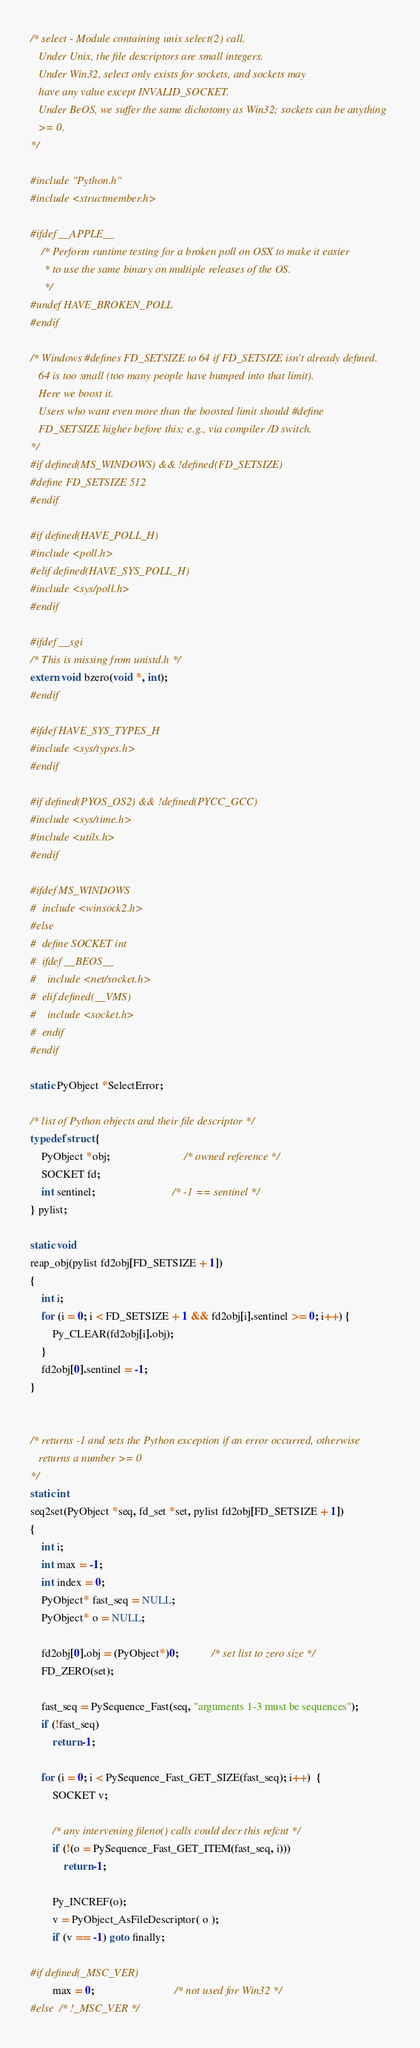<code> <loc_0><loc_0><loc_500><loc_500><_C_>/* select - Module containing unix select(2) call.
   Under Unix, the file descriptors are small integers.
   Under Win32, select only exists for sockets, and sockets may
   have any value except INVALID_SOCKET.
   Under BeOS, we suffer the same dichotomy as Win32; sockets can be anything
   >= 0.
*/

#include "Python.h"
#include <structmember.h>

#ifdef __APPLE__
    /* Perform runtime testing for a broken poll on OSX to make it easier
     * to use the same binary on multiple releases of the OS.
     */
#undef HAVE_BROKEN_POLL
#endif

/* Windows #defines FD_SETSIZE to 64 if FD_SETSIZE isn't already defined.
   64 is too small (too many people have bumped into that limit).
   Here we boost it.
   Users who want even more than the boosted limit should #define
   FD_SETSIZE higher before this; e.g., via compiler /D switch.
*/
#if defined(MS_WINDOWS) && !defined(FD_SETSIZE)
#define FD_SETSIZE 512
#endif

#if defined(HAVE_POLL_H)
#include <poll.h>
#elif defined(HAVE_SYS_POLL_H)
#include <sys/poll.h>
#endif

#ifdef __sgi
/* This is missing from unistd.h */
extern void bzero(void *, int);
#endif

#ifdef HAVE_SYS_TYPES_H
#include <sys/types.h>
#endif

#if defined(PYOS_OS2) && !defined(PYCC_GCC)
#include <sys/time.h>
#include <utils.h>
#endif

#ifdef MS_WINDOWS
#  include <winsock2.h>
#else
#  define SOCKET int
#  ifdef __BEOS__
#    include <net/socket.h>
#  elif defined(__VMS)
#    include <socket.h>
#  endif
#endif

static PyObject *SelectError;

/* list of Python objects and their file descriptor */
typedef struct {
    PyObject *obj;                           /* owned reference */
    SOCKET fd;
    int sentinel;                            /* -1 == sentinel */
} pylist;

static void
reap_obj(pylist fd2obj[FD_SETSIZE + 1])
{
    int i;
    for (i = 0; i < FD_SETSIZE + 1 && fd2obj[i].sentinel >= 0; i++) {
        Py_CLEAR(fd2obj[i].obj);
    }
    fd2obj[0].sentinel = -1;
}


/* returns -1 and sets the Python exception if an error occurred, otherwise
   returns a number >= 0
*/
static int
seq2set(PyObject *seq, fd_set *set, pylist fd2obj[FD_SETSIZE + 1])
{
    int i;
    int max = -1;
    int index = 0;
    PyObject* fast_seq = NULL;
    PyObject* o = NULL;

    fd2obj[0].obj = (PyObject*)0;            /* set list to zero size */
    FD_ZERO(set);

    fast_seq = PySequence_Fast(seq, "arguments 1-3 must be sequences");
    if (!fast_seq)
        return -1;

    for (i = 0; i < PySequence_Fast_GET_SIZE(fast_seq); i++)  {
        SOCKET v;

        /* any intervening fileno() calls could decr this refcnt */
        if (!(o = PySequence_Fast_GET_ITEM(fast_seq, i)))
            return -1;

        Py_INCREF(o);
        v = PyObject_AsFileDescriptor( o );
        if (v == -1) goto finally;

#if defined(_MSC_VER)
        max = 0;                             /* not used for Win32 */
#else  /* !_MSC_VER */</code> 